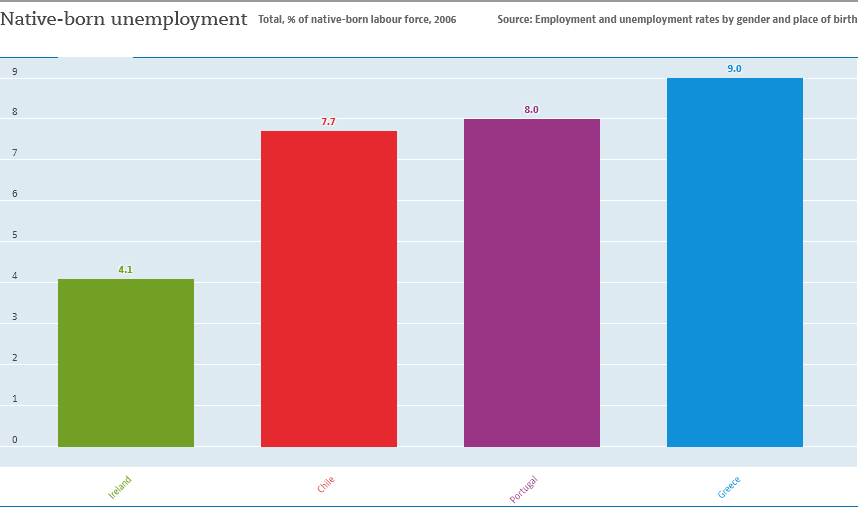Identify some key points in this picture. The value of the smallest bar is not equal to 1/2 the value of the largest bar. There are four bars in the graph. 